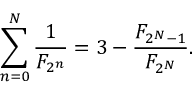<formula> <loc_0><loc_0><loc_500><loc_500>\sum _ { n = 0 } ^ { N } { \frac { 1 } { F _ { 2 ^ { n } } } } = 3 - { \frac { F _ { 2 ^ { N } - 1 } } { F _ { 2 ^ { N } } } } .</formula> 